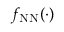<formula> <loc_0><loc_0><loc_500><loc_500>f _ { N N } ( \cdot )</formula> 